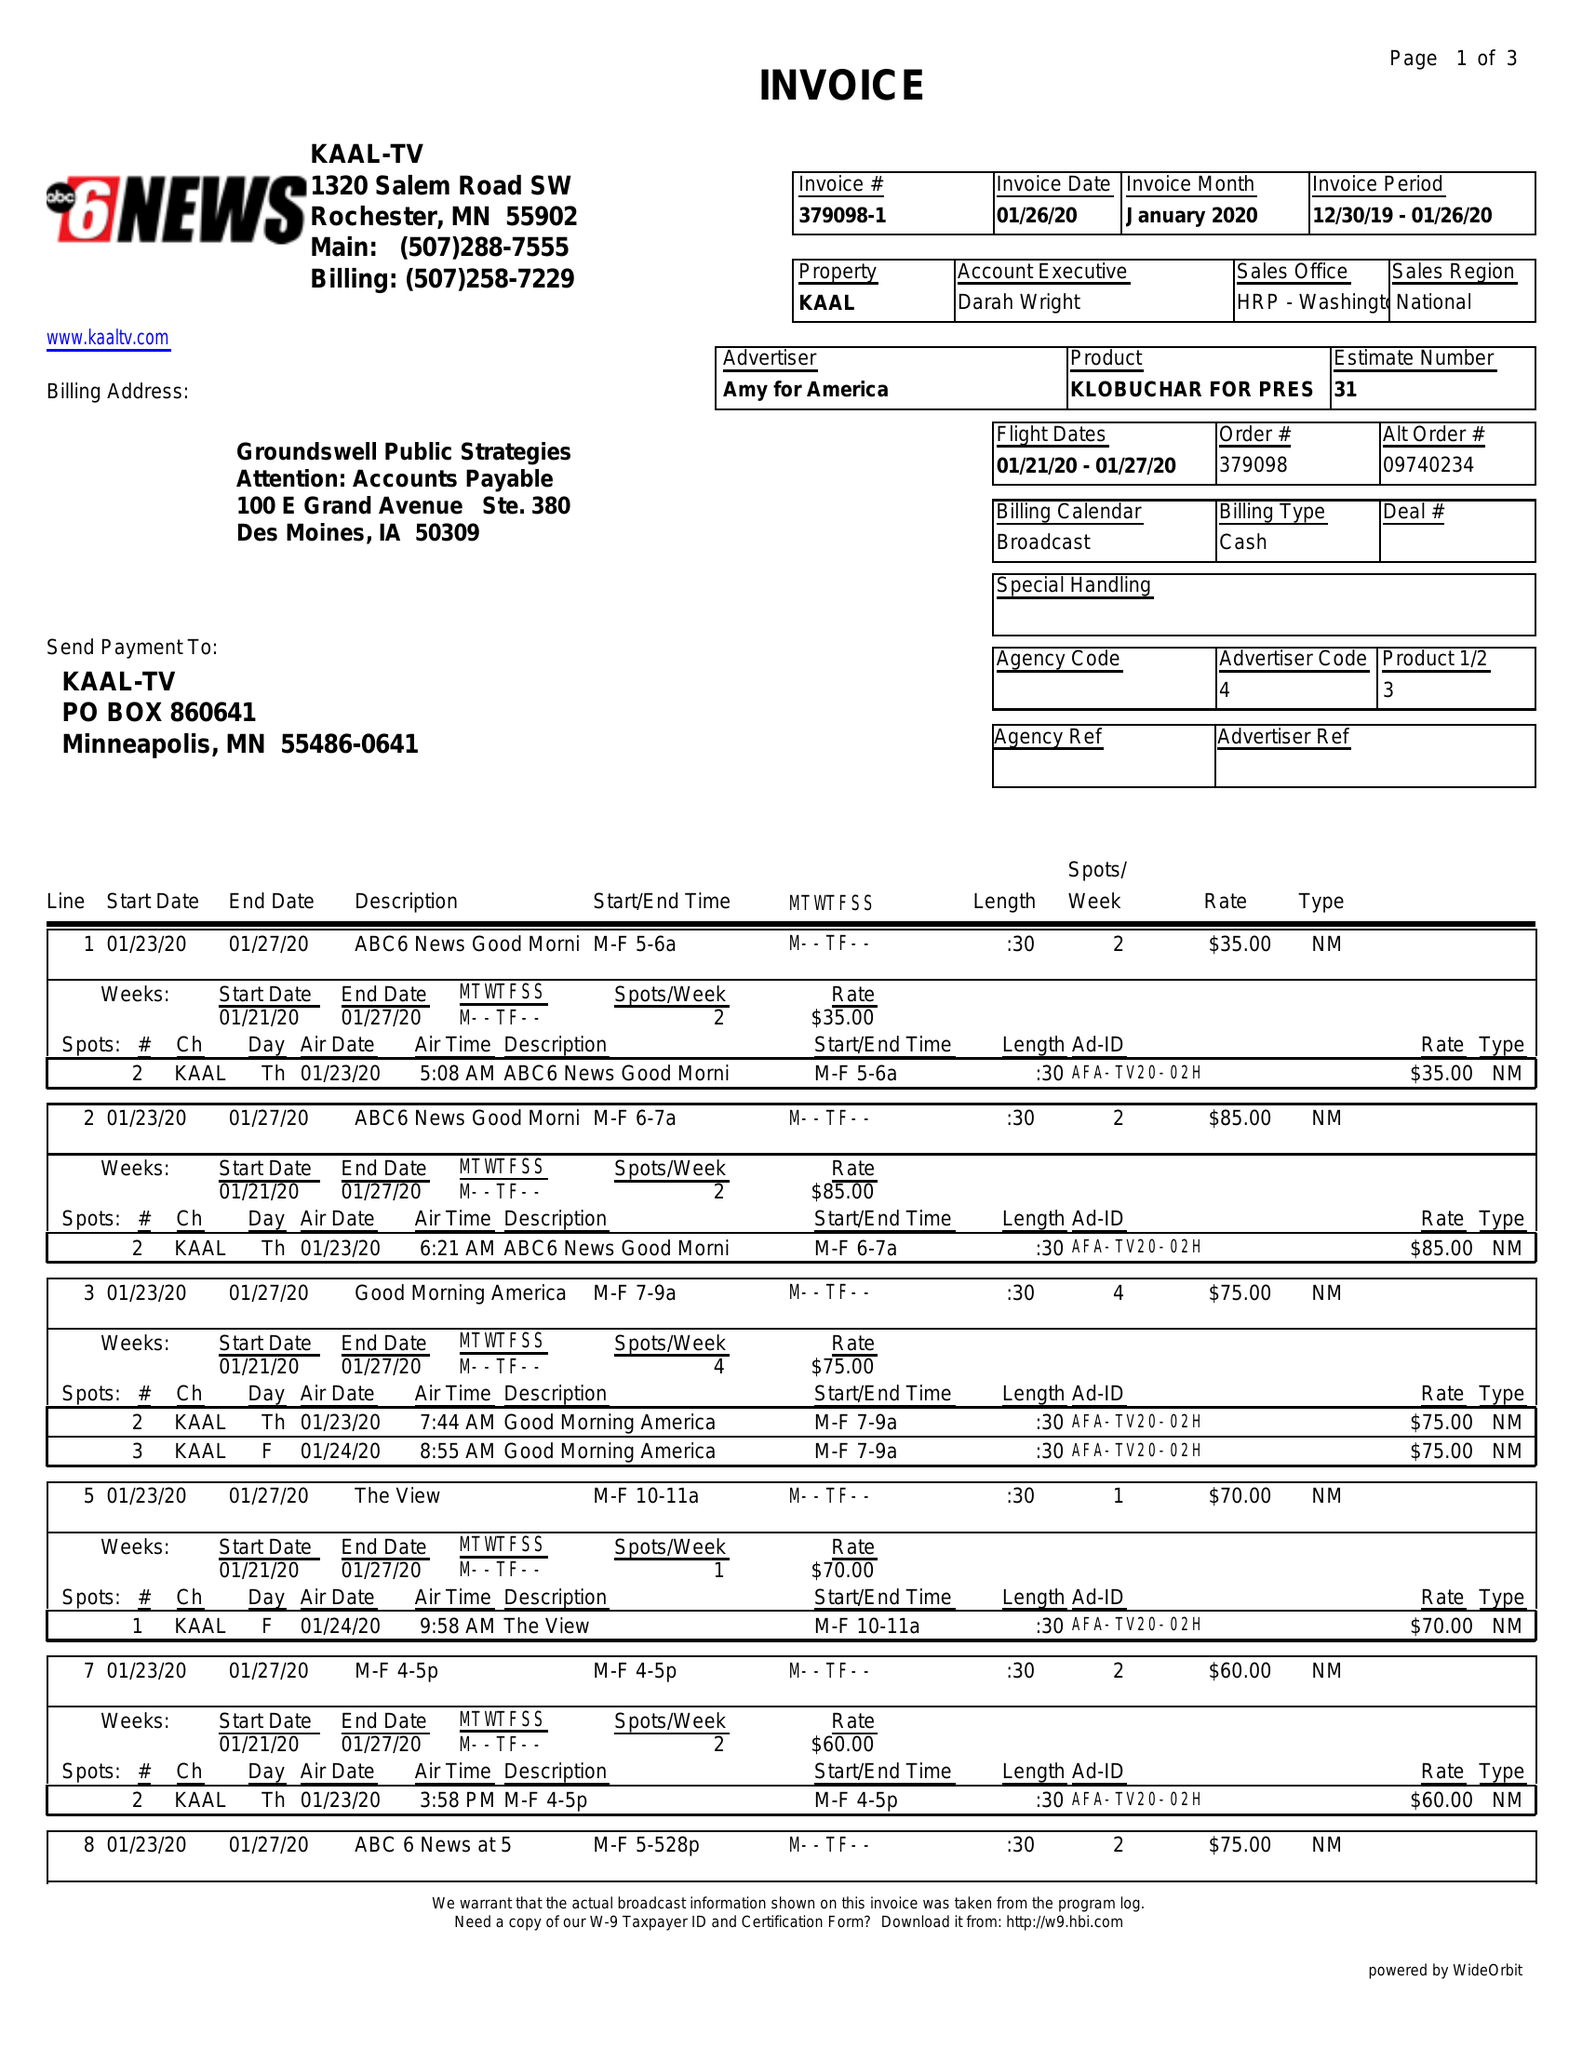What is the value for the contract_num?
Answer the question using a single word or phrase. 379098 